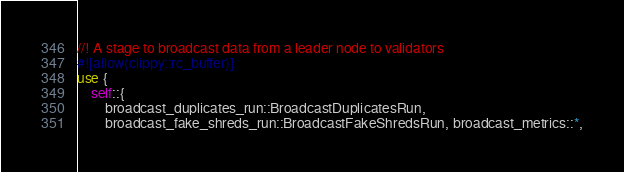<code> <loc_0><loc_0><loc_500><loc_500><_Rust_>//! A stage to broadcast data from a leader node to validators
#![allow(clippy::rc_buffer)]
use {
    self::{
        broadcast_duplicates_run::BroadcastDuplicatesRun,
        broadcast_fake_shreds_run::BroadcastFakeShredsRun, broadcast_metrics::*,</code> 